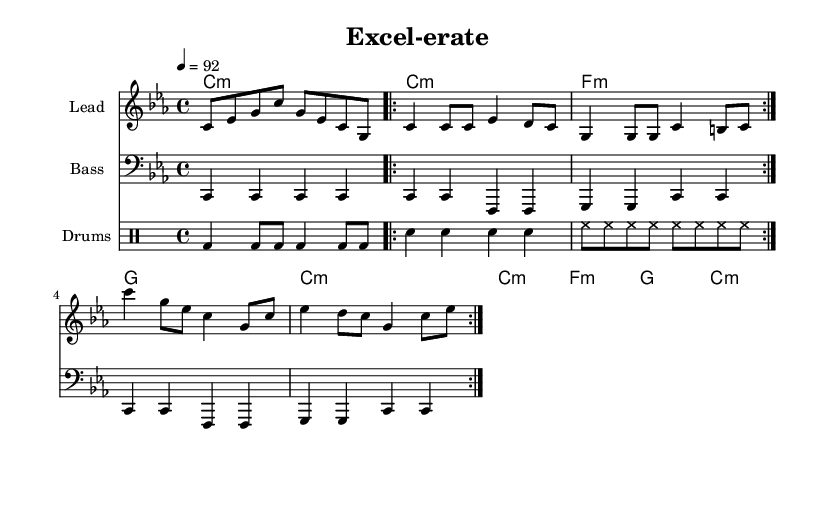What is the key signature of this music? The key signature is C minor, which has three flats (B, E, and A). This can be identified at the beginning of the staff, which shows the flats placed on the second line and the third line.
Answer: C minor What is the time signature of this piece? The time signature is four-four, indicated by the notation "4/4" found at the beginning of the score. This means there are four beats in each measure, and the quarter note gets one beat.
Answer: 4/4 What is the tempo marking for this piece? The tempo marking is 92 beats per minute, as indicated by "4 = 92" at the beginning of the piece. This number indicates the speed of the beat in quarter notes.
Answer: 92 How many measures are in the verse section? The verse section consists of 4 measures, determined by counting each segment from the repeat markings. Each line represents a measure, and the section is repeated twice, reinforcing the importance of this structure.
Answer: 4 What type of music is this score written for? This score is specifically written for Rap, indicated by its structure and lyrical focus on data analysis and spreadsheet themes. The rhythmic style and repetitive nature are common in Hip-hop tracks.
Answer: Rap What instruments are used in this score? The instruments used in this score are Lead, Bass, and Drums. This is evident from the labeled staves that indicate the different instrumental sections. Each staff presents musical information for a specific instrument.
Answer: Lead, Bass, Drums What is the last chord of the chorus section? The last chord of the chorus section is C minor. This is indicated in the harmonies where C minor appears at the end of the chorus after the other chords.
Answer: C minor 